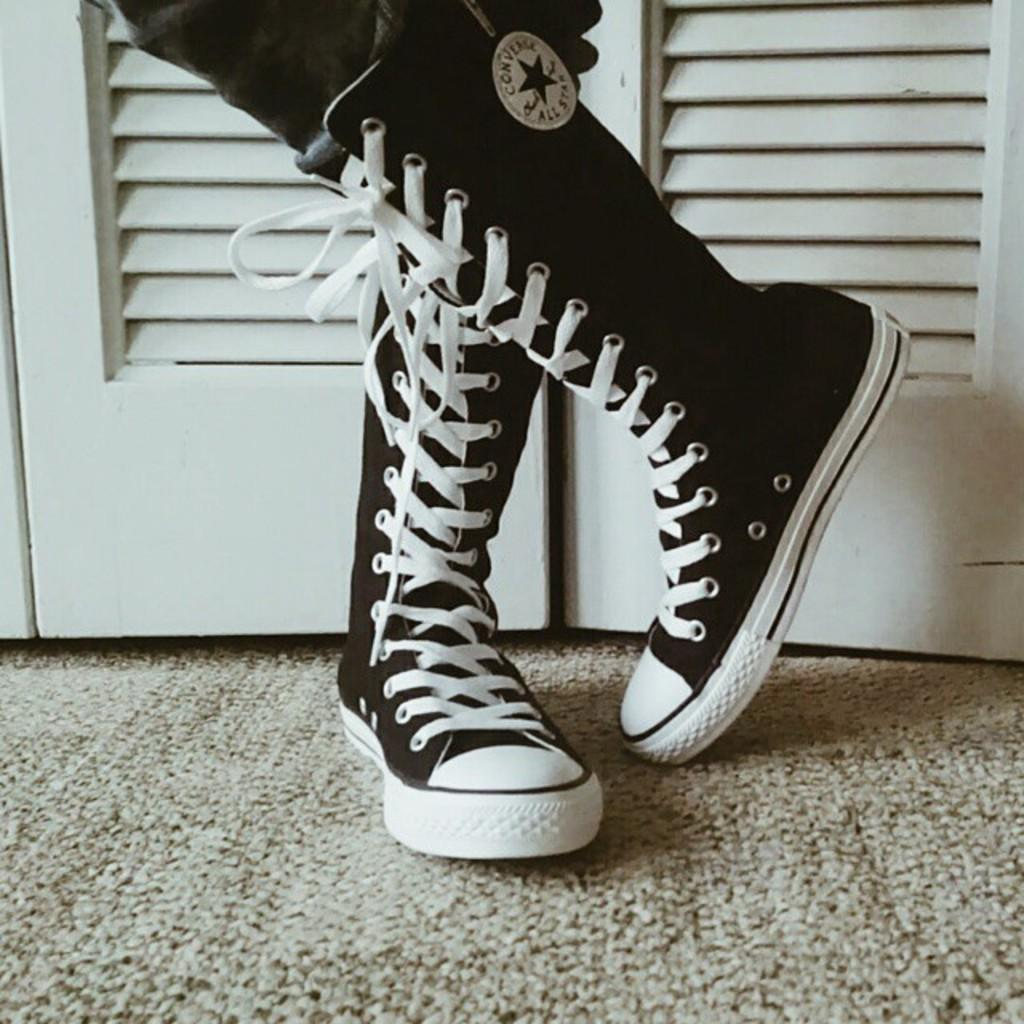Who or what is present in the image? There is a person in the image. What type of shoes is the person wearing? The person is wearing black and white shoes. Where are the shoes located in the image? The shoes are on a carpet. What can be seen in the background of the image? There are doors in the background of the image. What type of plough is being used in the image? There is no plough present in the image. Can you describe the beetle that is crawling on the person's shoes? There is no beetle visible on the shoes in the image. 